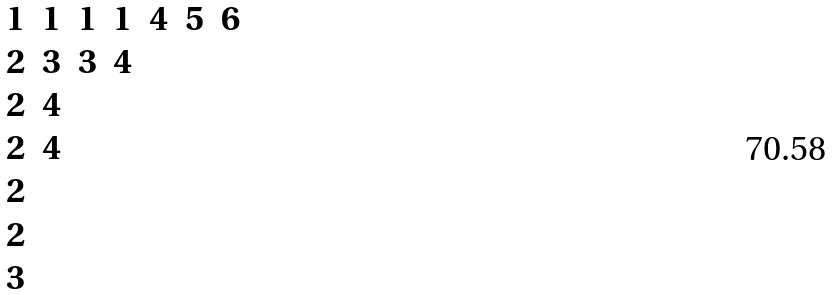Convert formula to latex. <formula><loc_0><loc_0><loc_500><loc_500>\begin{matrix} 1 & 1 & 1 & 1 & 4 & 5 & 6 \\ 2 & 3 & 3 & 4 \\ 2 & 4 \\ 2 & 4 \\ 2 \\ 2 \\ 3 \end{matrix}</formula> 